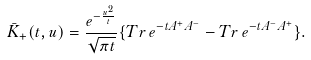<formula> <loc_0><loc_0><loc_500><loc_500>\bar { K } _ { + } ( t , u ) = \frac { e ^ { - \frac { u ^ { 2 } } { t } } } { \sqrt { \pi t } } \{ T r \, e ^ { - t A ^ { + } A ^ { - } } - T r \, e ^ { - t A ^ { - } A ^ { + } } \} .</formula> 